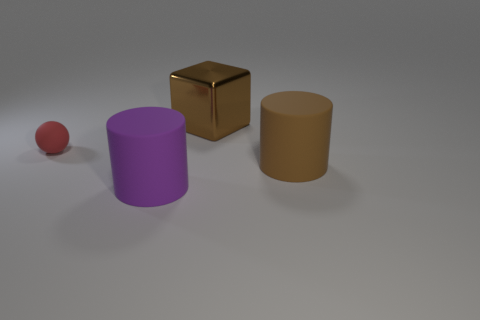Add 3 big green metal things. How many objects exist? 7 Subtract all cubes. How many objects are left? 3 Add 2 small gray shiny spheres. How many small gray shiny spheres exist? 2 Subtract 0 gray spheres. How many objects are left? 4 Subtract all large matte cylinders. Subtract all blocks. How many objects are left? 1 Add 1 big metal cubes. How many big metal cubes are left? 2 